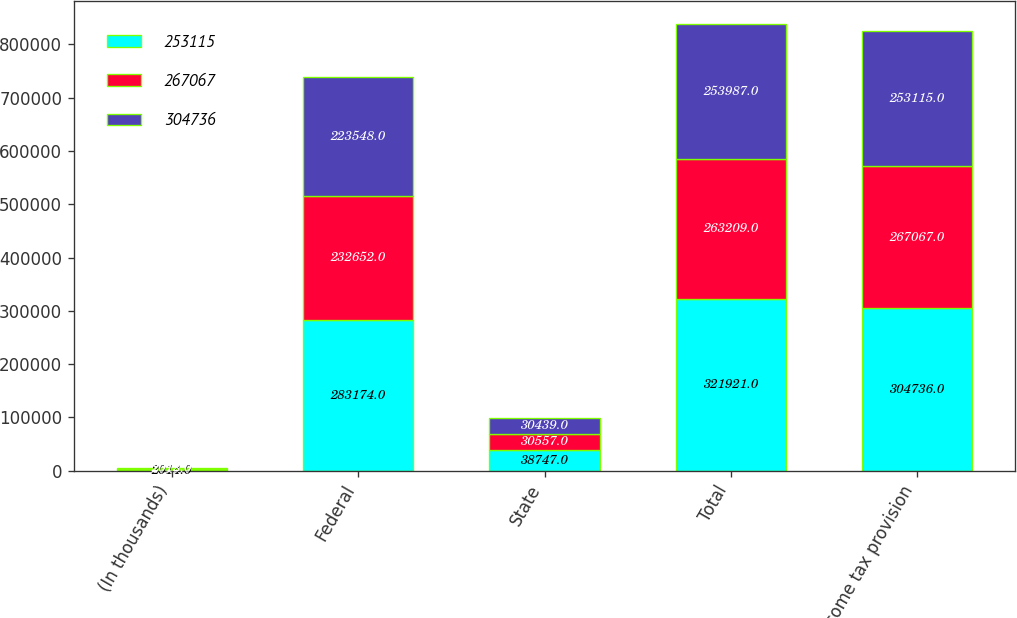<chart> <loc_0><loc_0><loc_500><loc_500><stacked_bar_chart><ecel><fcel>(In thousands)<fcel>Federal<fcel>State<fcel>Total<fcel>Income tax provision<nl><fcel>253115<fcel>2014<fcel>283174<fcel>38747<fcel>321921<fcel>304736<nl><fcel>267067<fcel>2013<fcel>232652<fcel>30557<fcel>263209<fcel>267067<nl><fcel>304736<fcel>2012<fcel>223548<fcel>30439<fcel>253987<fcel>253115<nl></chart> 